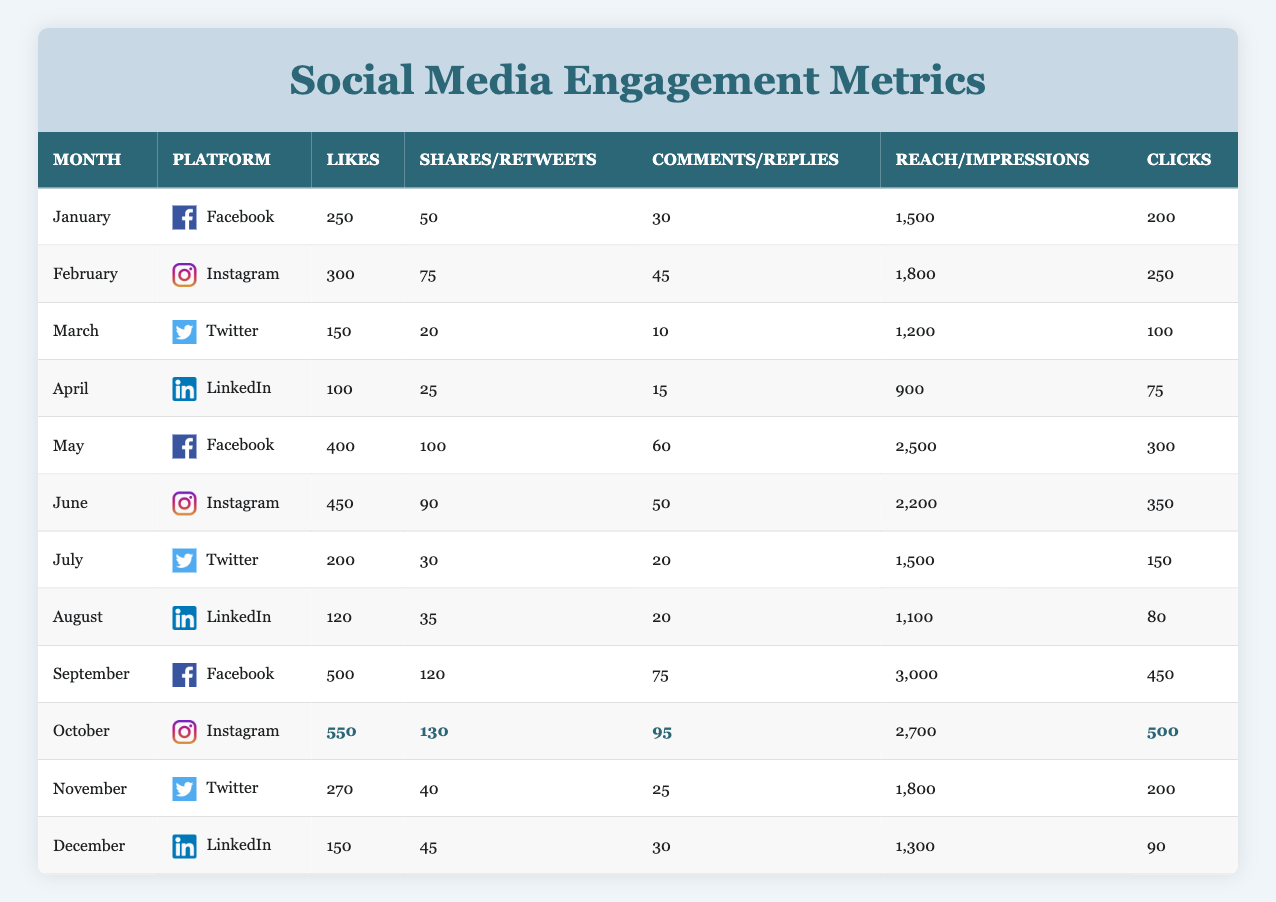What was the highest number of likes received in a single month? The highest number of likes can be found by scanning through the "Likes" column. Upon reviewing the data, October had the highest likes, totaling 550.
Answer: 550 Which platform received the most shares over the year? To find the platform with the most shares, I will sum up the shares for Facebook, Instagram, Twitter, and LinkedIn across all months. Facebook has its highest share in September (120), Instagram in October (130), Twitter in July (30), and LinkedIn in June (90). Therefore, totaling them gives Facebook: 50 + 100 + 120 = 270, Instagram: 75 + 90 + 130 = 295, Twitter: 20 + 30 + 40 = 90, and LinkedIn: 25 + 35 + 45 = 105. Instagram received the most shares with 295.
Answer: Instagram Was the post reach in July greater than in April? Looking at the "Reach" for July (1,500) and April (900), I can see that July's reach is greater than April's reach. Since 1,500 is greater than 900, the statement is true.
Answer: Yes What is the total number of comments received on Facebook throughout the year? I need to add the comments from each month where Facebook was the platform. For Facebook, the comments are: January (30), May (60), September (75). Summing these gives 30 + 60 + 75 = 165.
Answer: 165 What was the average number of likes across all platforms in June? The likes in June by platform are as follows: Instagram (450). Since this is the only platform present in June and there are no other entries, the average is simply 450 divided by 1, which equals 450.
Answer: 450 In which month did LinkedIn have the highest engagement based on the sum of likes, shares, and comments? To find the month with the highest engagement for LinkedIn based on the sum of likes, shares, and comments, I will calculate for April and December. April: 100 + 25 + 15 = 140, December: 150 + 45 + 30 = 225. December has the highest engagement at 225.
Answer: December How many clicks were generated on Instagram months compared to Twitter months, and which was higher? For Instagram, I will sum the clicks in February (250), June (350), and October (500), totaling 1,100. For Twitter, the clicks in March (100), July (150), and November (200) total 450. Since 1,100 is greater than 450, Instagram generated more clicks.
Answer: Instagram Was there a month when the total number of clicks across all platforms was over 1,000? I need to check the clicks for each month: January (200), February (250), March (100), April (75), May (300), June (350), July (150), August (80), September (450), October (500), November (200), December (90). The total for September (450) and October (500) combined gives 950, which is less than 1,000, but looking solely at October gives us over 1,000. So there were months where clicks exceeded 1,000.
Answer: Yes 